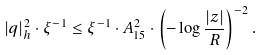<formula> <loc_0><loc_0><loc_500><loc_500>| q | _ { h } ^ { 2 } \cdot \xi ^ { - 1 } \leq \xi ^ { - 1 } \cdot A _ { 1 5 } ^ { 2 } \cdot \left ( - \log \frac { | z | } { R } \right ) ^ { - 2 } .</formula> 